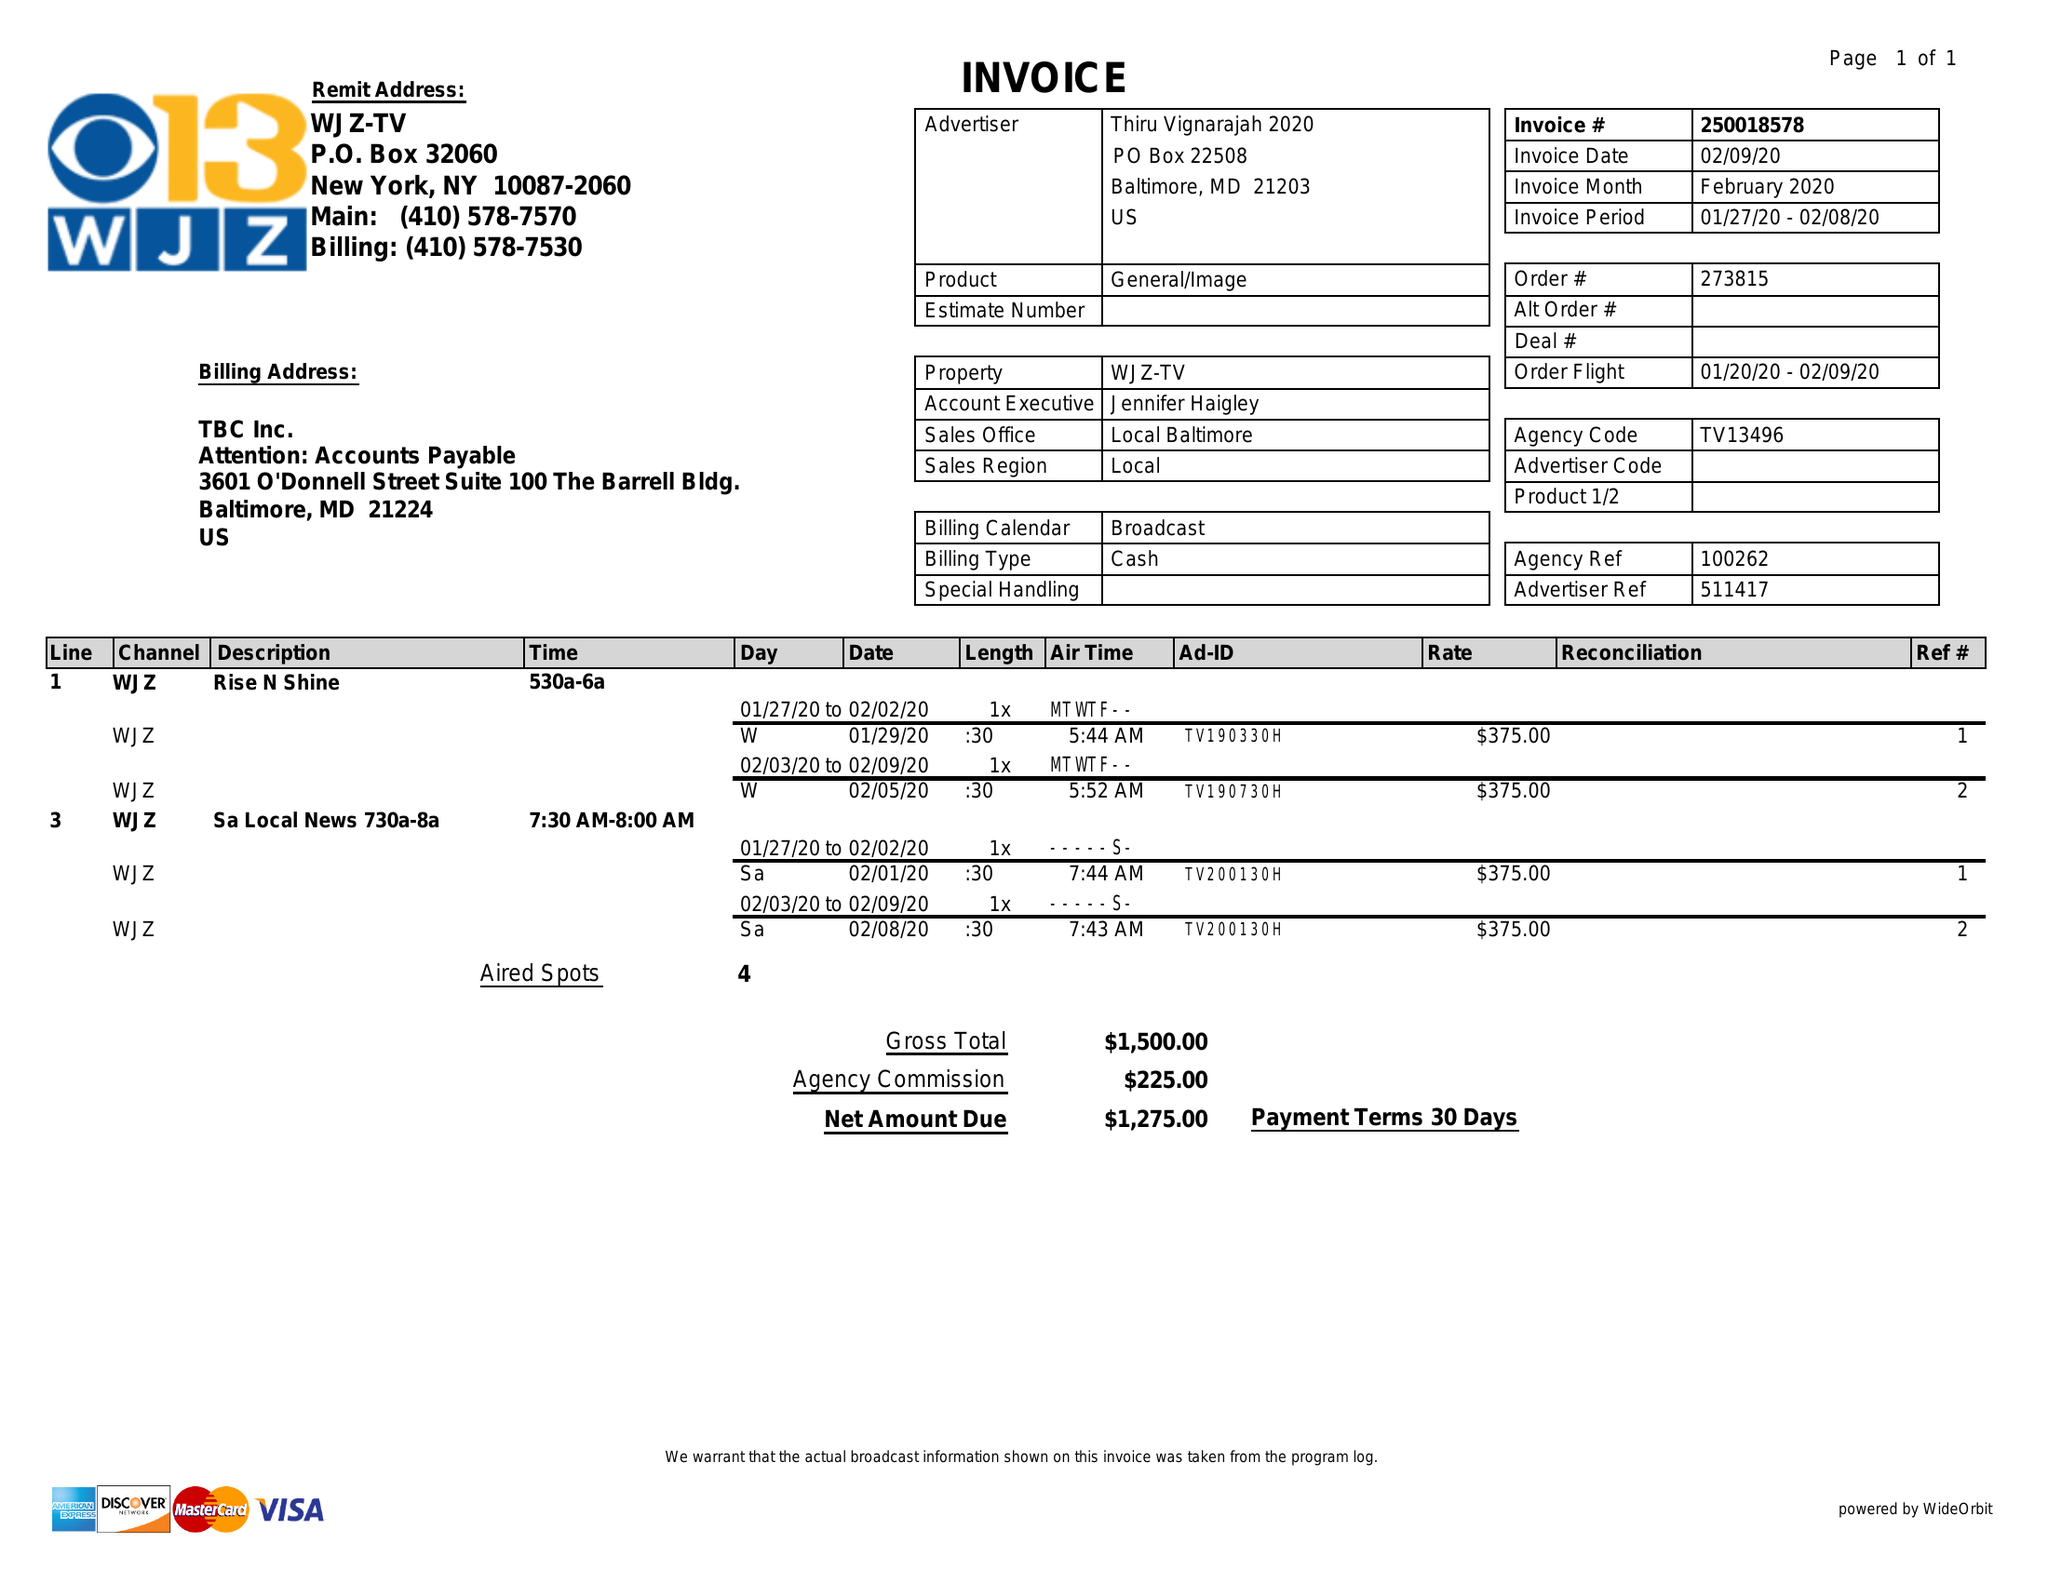What is the value for the flight_from?
Answer the question using a single word or phrase. 01/20/20 